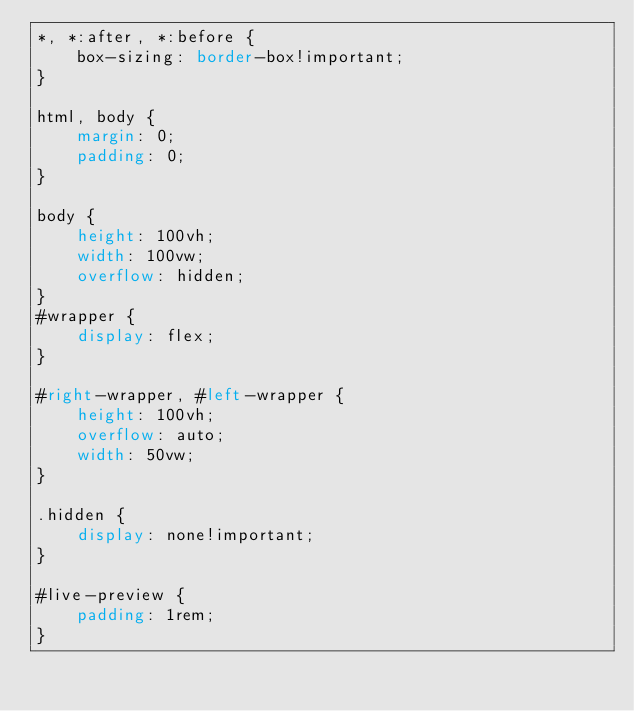<code> <loc_0><loc_0><loc_500><loc_500><_CSS_>*, *:after, *:before {
	box-sizing: border-box!important;
}

html, body {
	margin: 0;
	padding: 0;
}

body {
	height: 100vh;
	width: 100vw;
	overflow: hidden;
}
#wrapper {
	display: flex;
}

#right-wrapper, #left-wrapper {
	height: 100vh;
	overflow: auto;
	width: 50vw;
}

.hidden {
	display: none!important;
}

#live-preview {
	padding: 1rem;
}
</code> 